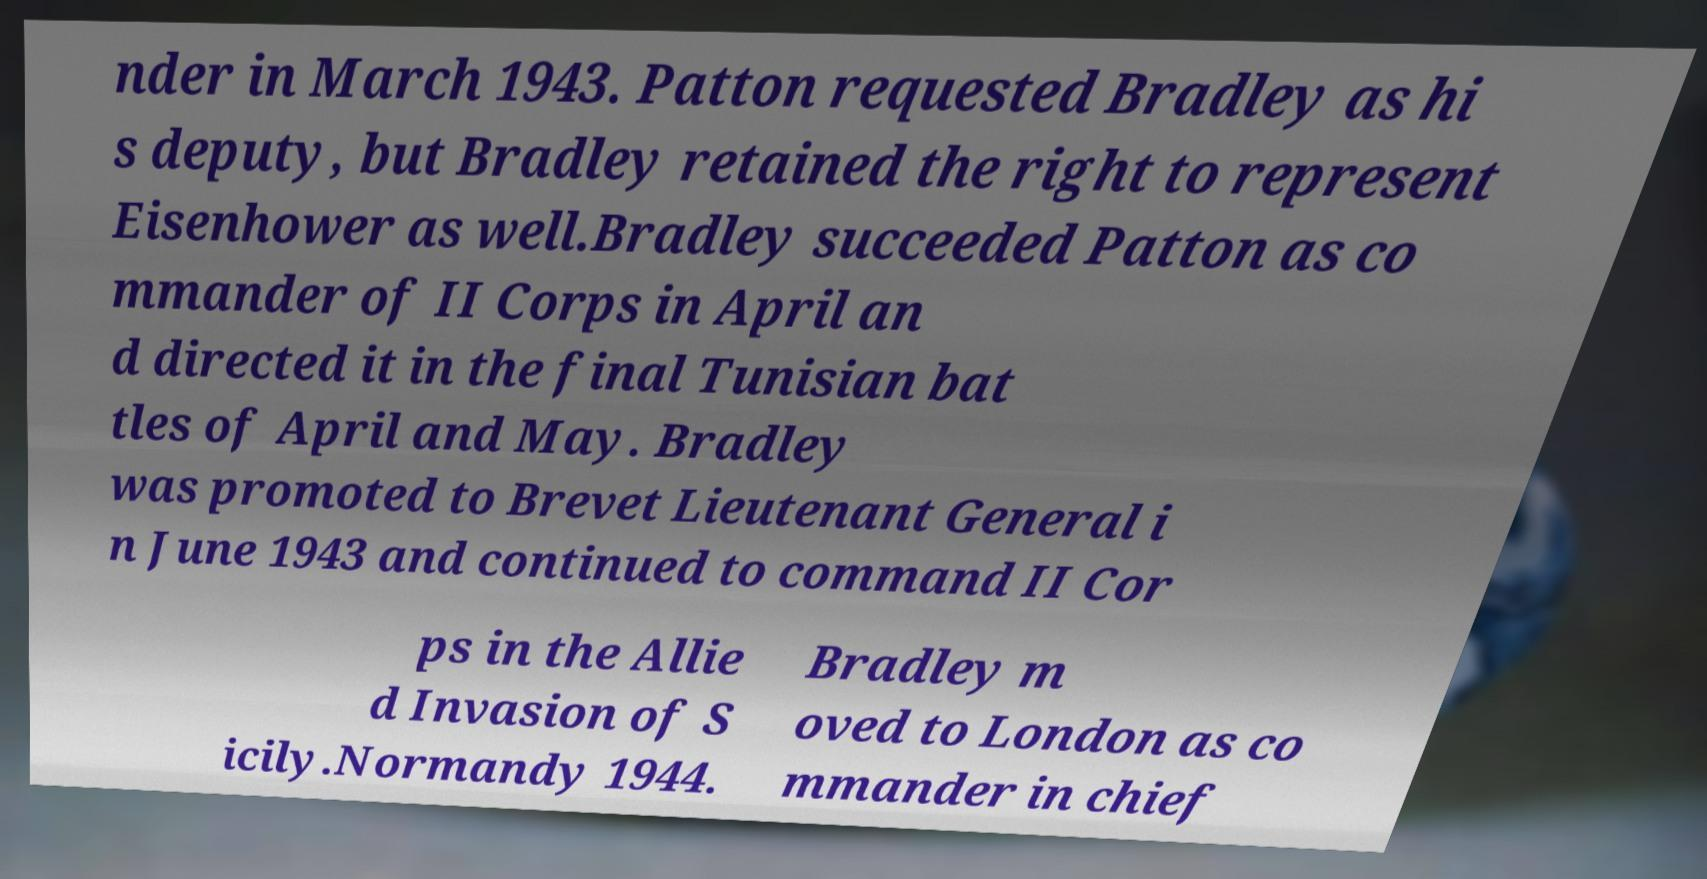For documentation purposes, I need the text within this image transcribed. Could you provide that? nder in March 1943. Patton requested Bradley as hi s deputy, but Bradley retained the right to represent Eisenhower as well.Bradley succeeded Patton as co mmander of II Corps in April an d directed it in the final Tunisian bat tles of April and May. Bradley was promoted to Brevet Lieutenant General i n June 1943 and continued to command II Cor ps in the Allie d Invasion of S icily.Normandy 1944. Bradley m oved to London as co mmander in chief 